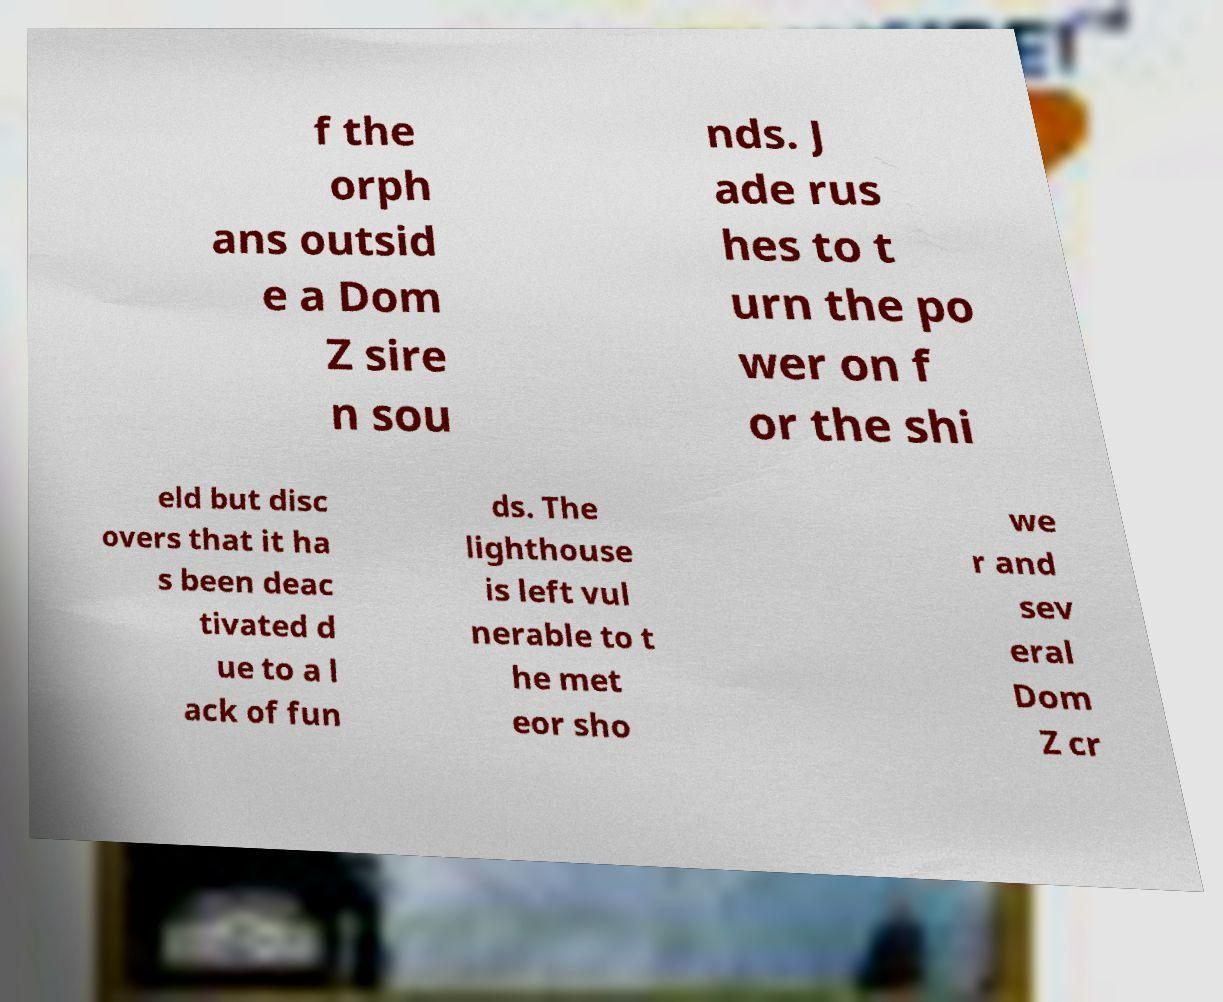Can you read and provide the text displayed in the image?This photo seems to have some interesting text. Can you extract and type it out for me? f the orph ans outsid e a Dom Z sire n sou nds. J ade rus hes to t urn the po wer on f or the shi eld but disc overs that it ha s been deac tivated d ue to a l ack of fun ds. The lighthouse is left vul nerable to t he met eor sho we r and sev eral Dom Z cr 